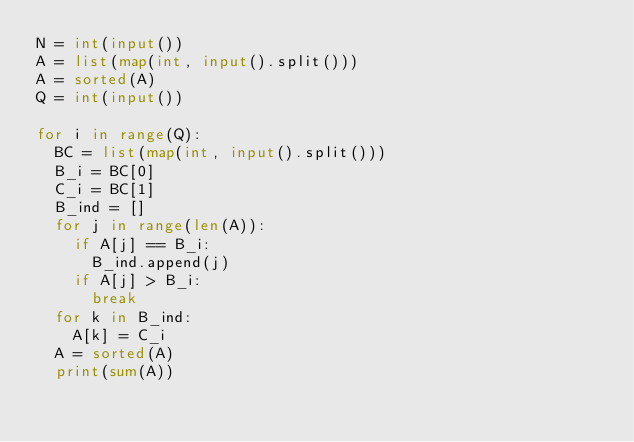<code> <loc_0><loc_0><loc_500><loc_500><_Python_>N = int(input())
A = list(map(int, input().split()))
A = sorted(A)
Q = int(input())

for i in range(Q):
  BC = list(map(int, input().split()))
  B_i = BC[0]
  C_i = BC[1]
  B_ind = []
  for j in range(len(A)):
    if A[j] == B_i:
      B_ind.append(j)
    if A[j] > B_i:
      break
  for k in B_ind:
    A[k] = C_i
  A = sorted(A)
  print(sum(A))
  </code> 